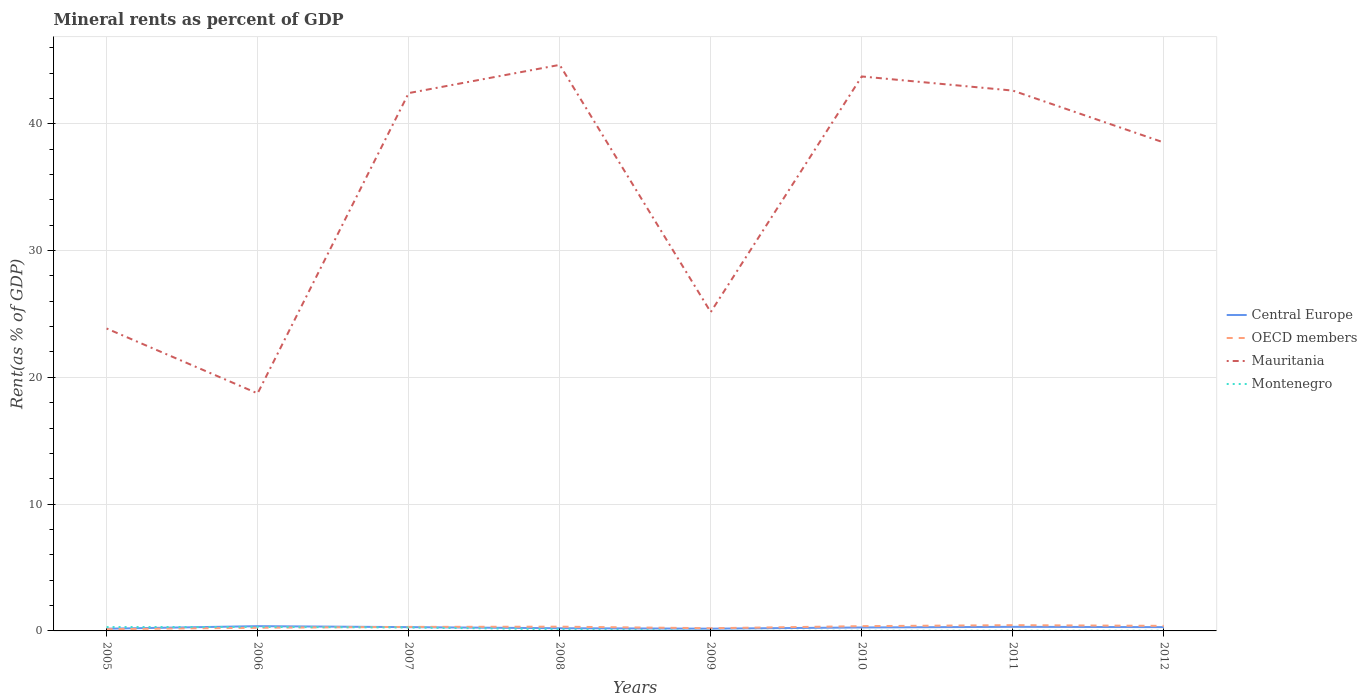How many different coloured lines are there?
Keep it short and to the point. 4. Does the line corresponding to OECD members intersect with the line corresponding to Montenegro?
Provide a succinct answer. Yes. Is the number of lines equal to the number of legend labels?
Keep it short and to the point. Yes. Across all years, what is the maximum mineral rent in Mauritania?
Make the answer very short. 18.73. In which year was the mineral rent in OECD members maximum?
Give a very brief answer. 2005. What is the total mineral rent in OECD members in the graph?
Offer a very short reply. -0.04. What is the difference between the highest and the second highest mineral rent in Montenegro?
Offer a very short reply. 0.3. How many years are there in the graph?
Your answer should be compact. 8. What is the difference between two consecutive major ticks on the Y-axis?
Provide a succinct answer. 10. Are the values on the major ticks of Y-axis written in scientific E-notation?
Make the answer very short. No. Does the graph contain any zero values?
Keep it short and to the point. No. Does the graph contain grids?
Make the answer very short. Yes. Where does the legend appear in the graph?
Ensure brevity in your answer.  Center right. What is the title of the graph?
Your answer should be very brief. Mineral rents as percent of GDP. What is the label or title of the X-axis?
Provide a succinct answer. Years. What is the label or title of the Y-axis?
Offer a very short reply. Rent(as % of GDP). What is the Rent(as % of GDP) in Central Europe in 2005?
Provide a short and direct response. 0.18. What is the Rent(as % of GDP) in OECD members in 2005?
Provide a succinct answer. 0.14. What is the Rent(as % of GDP) of Mauritania in 2005?
Ensure brevity in your answer.  23.85. What is the Rent(as % of GDP) in Montenegro in 2005?
Offer a terse response. 0.3. What is the Rent(as % of GDP) of Central Europe in 2006?
Your response must be concise. 0.38. What is the Rent(as % of GDP) of OECD members in 2006?
Give a very brief answer. 0.25. What is the Rent(as % of GDP) of Mauritania in 2006?
Offer a terse response. 18.73. What is the Rent(as % of GDP) of Montenegro in 2006?
Make the answer very short. 0.31. What is the Rent(as % of GDP) of Central Europe in 2007?
Provide a short and direct response. 0.3. What is the Rent(as % of GDP) of OECD members in 2007?
Your answer should be very brief. 0.32. What is the Rent(as % of GDP) in Mauritania in 2007?
Your answer should be compact. 42.42. What is the Rent(as % of GDP) of Montenegro in 2007?
Give a very brief answer. 0.27. What is the Rent(as % of GDP) of Central Europe in 2008?
Your response must be concise. 0.21. What is the Rent(as % of GDP) of OECD members in 2008?
Ensure brevity in your answer.  0.34. What is the Rent(as % of GDP) in Mauritania in 2008?
Ensure brevity in your answer.  44.64. What is the Rent(as % of GDP) of Montenegro in 2008?
Provide a succinct answer. 0.13. What is the Rent(as % of GDP) of Central Europe in 2009?
Give a very brief answer. 0.18. What is the Rent(as % of GDP) of OECD members in 2009?
Your answer should be compact. 0.21. What is the Rent(as % of GDP) in Mauritania in 2009?
Your response must be concise. 25.14. What is the Rent(as % of GDP) in Montenegro in 2009?
Make the answer very short. 0.01. What is the Rent(as % of GDP) in Central Europe in 2010?
Ensure brevity in your answer.  0.27. What is the Rent(as % of GDP) in OECD members in 2010?
Make the answer very short. 0.38. What is the Rent(as % of GDP) of Mauritania in 2010?
Offer a terse response. 43.73. What is the Rent(as % of GDP) in Montenegro in 2010?
Provide a succinct answer. 0.02. What is the Rent(as % of GDP) of Central Europe in 2011?
Provide a short and direct response. 0.32. What is the Rent(as % of GDP) of OECD members in 2011?
Give a very brief answer. 0.46. What is the Rent(as % of GDP) in Mauritania in 2011?
Make the answer very short. 42.62. What is the Rent(as % of GDP) in Montenegro in 2011?
Make the answer very short. 0.02. What is the Rent(as % of GDP) in Central Europe in 2012?
Your answer should be very brief. 0.3. What is the Rent(as % of GDP) of OECD members in 2012?
Make the answer very short. 0.4. What is the Rent(as % of GDP) in Mauritania in 2012?
Ensure brevity in your answer.  38.52. What is the Rent(as % of GDP) of Montenegro in 2012?
Your answer should be very brief. 0.01. Across all years, what is the maximum Rent(as % of GDP) of Central Europe?
Provide a short and direct response. 0.38. Across all years, what is the maximum Rent(as % of GDP) in OECD members?
Offer a very short reply. 0.46. Across all years, what is the maximum Rent(as % of GDP) of Mauritania?
Provide a short and direct response. 44.64. Across all years, what is the maximum Rent(as % of GDP) in Montenegro?
Your response must be concise. 0.31. Across all years, what is the minimum Rent(as % of GDP) in Central Europe?
Offer a very short reply. 0.18. Across all years, what is the minimum Rent(as % of GDP) in OECD members?
Offer a very short reply. 0.14. Across all years, what is the minimum Rent(as % of GDP) of Mauritania?
Your response must be concise. 18.73. Across all years, what is the minimum Rent(as % of GDP) in Montenegro?
Keep it short and to the point. 0.01. What is the total Rent(as % of GDP) of Central Europe in the graph?
Your response must be concise. 2.14. What is the total Rent(as % of GDP) in OECD members in the graph?
Provide a short and direct response. 2.48. What is the total Rent(as % of GDP) of Mauritania in the graph?
Provide a short and direct response. 279.66. What is the total Rent(as % of GDP) of Montenegro in the graph?
Give a very brief answer. 1.08. What is the difference between the Rent(as % of GDP) in Central Europe in 2005 and that in 2006?
Provide a succinct answer. -0.2. What is the difference between the Rent(as % of GDP) of OECD members in 2005 and that in 2006?
Your answer should be very brief. -0.11. What is the difference between the Rent(as % of GDP) in Mauritania in 2005 and that in 2006?
Offer a terse response. 5.12. What is the difference between the Rent(as % of GDP) of Montenegro in 2005 and that in 2006?
Offer a terse response. -0.01. What is the difference between the Rent(as % of GDP) of Central Europe in 2005 and that in 2007?
Offer a very short reply. -0.12. What is the difference between the Rent(as % of GDP) of OECD members in 2005 and that in 2007?
Provide a short and direct response. -0.18. What is the difference between the Rent(as % of GDP) of Mauritania in 2005 and that in 2007?
Make the answer very short. -18.57. What is the difference between the Rent(as % of GDP) in Montenegro in 2005 and that in 2007?
Offer a terse response. 0.03. What is the difference between the Rent(as % of GDP) in Central Europe in 2005 and that in 2008?
Give a very brief answer. -0.04. What is the difference between the Rent(as % of GDP) of OECD members in 2005 and that in 2008?
Ensure brevity in your answer.  -0.2. What is the difference between the Rent(as % of GDP) of Mauritania in 2005 and that in 2008?
Your answer should be very brief. -20.79. What is the difference between the Rent(as % of GDP) in Montenegro in 2005 and that in 2008?
Your answer should be very brief. 0.18. What is the difference between the Rent(as % of GDP) in Central Europe in 2005 and that in 2009?
Provide a short and direct response. -0. What is the difference between the Rent(as % of GDP) in OECD members in 2005 and that in 2009?
Offer a terse response. -0.08. What is the difference between the Rent(as % of GDP) in Mauritania in 2005 and that in 2009?
Ensure brevity in your answer.  -1.29. What is the difference between the Rent(as % of GDP) of Montenegro in 2005 and that in 2009?
Offer a very short reply. 0.29. What is the difference between the Rent(as % of GDP) of Central Europe in 2005 and that in 2010?
Keep it short and to the point. -0.1. What is the difference between the Rent(as % of GDP) of OECD members in 2005 and that in 2010?
Your answer should be compact. -0.24. What is the difference between the Rent(as % of GDP) in Mauritania in 2005 and that in 2010?
Give a very brief answer. -19.88. What is the difference between the Rent(as % of GDP) in Montenegro in 2005 and that in 2010?
Your answer should be very brief. 0.29. What is the difference between the Rent(as % of GDP) in Central Europe in 2005 and that in 2011?
Give a very brief answer. -0.15. What is the difference between the Rent(as % of GDP) in OECD members in 2005 and that in 2011?
Keep it short and to the point. -0.32. What is the difference between the Rent(as % of GDP) in Mauritania in 2005 and that in 2011?
Provide a succinct answer. -18.76. What is the difference between the Rent(as % of GDP) in Montenegro in 2005 and that in 2011?
Make the answer very short. 0.29. What is the difference between the Rent(as % of GDP) in Central Europe in 2005 and that in 2012?
Offer a very short reply. -0.12. What is the difference between the Rent(as % of GDP) in OECD members in 2005 and that in 2012?
Give a very brief answer. -0.26. What is the difference between the Rent(as % of GDP) in Mauritania in 2005 and that in 2012?
Your answer should be compact. -14.67. What is the difference between the Rent(as % of GDP) in Montenegro in 2005 and that in 2012?
Offer a very short reply. 0.29. What is the difference between the Rent(as % of GDP) of Central Europe in 2006 and that in 2007?
Your answer should be very brief. 0.08. What is the difference between the Rent(as % of GDP) of OECD members in 2006 and that in 2007?
Provide a short and direct response. -0.07. What is the difference between the Rent(as % of GDP) in Mauritania in 2006 and that in 2007?
Offer a very short reply. -23.69. What is the difference between the Rent(as % of GDP) in Montenegro in 2006 and that in 2007?
Your answer should be very brief. 0.04. What is the difference between the Rent(as % of GDP) of Central Europe in 2006 and that in 2008?
Your answer should be compact. 0.16. What is the difference between the Rent(as % of GDP) in OECD members in 2006 and that in 2008?
Provide a succinct answer. -0.09. What is the difference between the Rent(as % of GDP) in Mauritania in 2006 and that in 2008?
Offer a terse response. -25.91. What is the difference between the Rent(as % of GDP) in Montenegro in 2006 and that in 2008?
Make the answer very short. 0.19. What is the difference between the Rent(as % of GDP) of Central Europe in 2006 and that in 2009?
Provide a succinct answer. 0.2. What is the difference between the Rent(as % of GDP) of OECD members in 2006 and that in 2009?
Provide a short and direct response. 0.03. What is the difference between the Rent(as % of GDP) in Mauritania in 2006 and that in 2009?
Provide a short and direct response. -6.41. What is the difference between the Rent(as % of GDP) of Montenegro in 2006 and that in 2009?
Offer a terse response. 0.3. What is the difference between the Rent(as % of GDP) in Central Europe in 2006 and that in 2010?
Offer a terse response. 0.1. What is the difference between the Rent(as % of GDP) in OECD members in 2006 and that in 2010?
Your answer should be very brief. -0.13. What is the difference between the Rent(as % of GDP) in Mauritania in 2006 and that in 2010?
Ensure brevity in your answer.  -25. What is the difference between the Rent(as % of GDP) of Montenegro in 2006 and that in 2010?
Keep it short and to the point. 0.3. What is the difference between the Rent(as % of GDP) of Central Europe in 2006 and that in 2011?
Offer a very short reply. 0.05. What is the difference between the Rent(as % of GDP) of OECD members in 2006 and that in 2011?
Provide a short and direct response. -0.21. What is the difference between the Rent(as % of GDP) in Mauritania in 2006 and that in 2011?
Provide a short and direct response. -23.88. What is the difference between the Rent(as % of GDP) in Montenegro in 2006 and that in 2011?
Keep it short and to the point. 0.3. What is the difference between the Rent(as % of GDP) of Central Europe in 2006 and that in 2012?
Your answer should be compact. 0.08. What is the difference between the Rent(as % of GDP) of OECD members in 2006 and that in 2012?
Your response must be concise. -0.15. What is the difference between the Rent(as % of GDP) of Mauritania in 2006 and that in 2012?
Ensure brevity in your answer.  -19.79. What is the difference between the Rent(as % of GDP) in Montenegro in 2006 and that in 2012?
Offer a very short reply. 0.3. What is the difference between the Rent(as % of GDP) in Central Europe in 2007 and that in 2008?
Make the answer very short. 0.09. What is the difference between the Rent(as % of GDP) of OECD members in 2007 and that in 2008?
Keep it short and to the point. -0.02. What is the difference between the Rent(as % of GDP) in Mauritania in 2007 and that in 2008?
Your answer should be compact. -2.23. What is the difference between the Rent(as % of GDP) in Montenegro in 2007 and that in 2008?
Make the answer very short. 0.14. What is the difference between the Rent(as % of GDP) in Central Europe in 2007 and that in 2009?
Give a very brief answer. 0.12. What is the difference between the Rent(as % of GDP) of OECD members in 2007 and that in 2009?
Ensure brevity in your answer.  0.1. What is the difference between the Rent(as % of GDP) of Mauritania in 2007 and that in 2009?
Make the answer very short. 17.27. What is the difference between the Rent(as % of GDP) of Montenegro in 2007 and that in 2009?
Provide a short and direct response. 0.26. What is the difference between the Rent(as % of GDP) in Central Europe in 2007 and that in 2010?
Your response must be concise. 0.03. What is the difference between the Rent(as % of GDP) in OECD members in 2007 and that in 2010?
Provide a succinct answer. -0.06. What is the difference between the Rent(as % of GDP) of Mauritania in 2007 and that in 2010?
Provide a short and direct response. -1.31. What is the difference between the Rent(as % of GDP) of Montenegro in 2007 and that in 2010?
Your answer should be very brief. 0.26. What is the difference between the Rent(as % of GDP) of Central Europe in 2007 and that in 2011?
Your response must be concise. -0.02. What is the difference between the Rent(as % of GDP) in OECD members in 2007 and that in 2011?
Keep it short and to the point. -0.14. What is the difference between the Rent(as % of GDP) of Mauritania in 2007 and that in 2011?
Provide a succinct answer. -0.2. What is the difference between the Rent(as % of GDP) of Montenegro in 2007 and that in 2011?
Provide a succinct answer. 0.26. What is the difference between the Rent(as % of GDP) in OECD members in 2007 and that in 2012?
Keep it short and to the point. -0.08. What is the difference between the Rent(as % of GDP) in Mauritania in 2007 and that in 2012?
Your response must be concise. 3.9. What is the difference between the Rent(as % of GDP) of Montenegro in 2007 and that in 2012?
Offer a terse response. 0.26. What is the difference between the Rent(as % of GDP) in Central Europe in 2008 and that in 2009?
Ensure brevity in your answer.  0.03. What is the difference between the Rent(as % of GDP) in OECD members in 2008 and that in 2009?
Your answer should be very brief. 0.12. What is the difference between the Rent(as % of GDP) of Mauritania in 2008 and that in 2009?
Give a very brief answer. 19.5. What is the difference between the Rent(as % of GDP) of Montenegro in 2008 and that in 2009?
Keep it short and to the point. 0.12. What is the difference between the Rent(as % of GDP) in Central Europe in 2008 and that in 2010?
Keep it short and to the point. -0.06. What is the difference between the Rent(as % of GDP) of OECD members in 2008 and that in 2010?
Provide a succinct answer. -0.04. What is the difference between the Rent(as % of GDP) of Mauritania in 2008 and that in 2010?
Your answer should be very brief. 0.91. What is the difference between the Rent(as % of GDP) of Montenegro in 2008 and that in 2010?
Keep it short and to the point. 0.11. What is the difference between the Rent(as % of GDP) of Central Europe in 2008 and that in 2011?
Keep it short and to the point. -0.11. What is the difference between the Rent(as % of GDP) in OECD members in 2008 and that in 2011?
Offer a terse response. -0.12. What is the difference between the Rent(as % of GDP) of Mauritania in 2008 and that in 2011?
Offer a very short reply. 2.03. What is the difference between the Rent(as % of GDP) of Montenegro in 2008 and that in 2011?
Your response must be concise. 0.11. What is the difference between the Rent(as % of GDP) of Central Europe in 2008 and that in 2012?
Make the answer very short. -0.09. What is the difference between the Rent(as % of GDP) in OECD members in 2008 and that in 2012?
Your response must be concise. -0.06. What is the difference between the Rent(as % of GDP) of Mauritania in 2008 and that in 2012?
Make the answer very short. 6.12. What is the difference between the Rent(as % of GDP) of Montenegro in 2008 and that in 2012?
Your answer should be very brief. 0.11. What is the difference between the Rent(as % of GDP) of Central Europe in 2009 and that in 2010?
Your answer should be compact. -0.09. What is the difference between the Rent(as % of GDP) of OECD members in 2009 and that in 2010?
Your answer should be compact. -0.16. What is the difference between the Rent(as % of GDP) in Mauritania in 2009 and that in 2010?
Ensure brevity in your answer.  -18.59. What is the difference between the Rent(as % of GDP) of Montenegro in 2009 and that in 2010?
Provide a short and direct response. -0. What is the difference between the Rent(as % of GDP) of Central Europe in 2009 and that in 2011?
Offer a very short reply. -0.15. What is the difference between the Rent(as % of GDP) in OECD members in 2009 and that in 2011?
Make the answer very short. -0.24. What is the difference between the Rent(as % of GDP) in Mauritania in 2009 and that in 2011?
Keep it short and to the point. -17.47. What is the difference between the Rent(as % of GDP) of Montenegro in 2009 and that in 2011?
Offer a very short reply. -0. What is the difference between the Rent(as % of GDP) of Central Europe in 2009 and that in 2012?
Your response must be concise. -0.12. What is the difference between the Rent(as % of GDP) in OECD members in 2009 and that in 2012?
Provide a short and direct response. -0.19. What is the difference between the Rent(as % of GDP) in Mauritania in 2009 and that in 2012?
Your response must be concise. -13.38. What is the difference between the Rent(as % of GDP) of Montenegro in 2009 and that in 2012?
Provide a short and direct response. -0. What is the difference between the Rent(as % of GDP) of Central Europe in 2010 and that in 2011?
Keep it short and to the point. -0.05. What is the difference between the Rent(as % of GDP) of OECD members in 2010 and that in 2011?
Ensure brevity in your answer.  -0.08. What is the difference between the Rent(as % of GDP) in Mauritania in 2010 and that in 2011?
Offer a terse response. 1.11. What is the difference between the Rent(as % of GDP) in Montenegro in 2010 and that in 2011?
Offer a very short reply. -0. What is the difference between the Rent(as % of GDP) of Central Europe in 2010 and that in 2012?
Offer a terse response. -0.03. What is the difference between the Rent(as % of GDP) of OECD members in 2010 and that in 2012?
Your response must be concise. -0.02. What is the difference between the Rent(as % of GDP) in Mauritania in 2010 and that in 2012?
Offer a terse response. 5.21. What is the difference between the Rent(as % of GDP) in Central Europe in 2011 and that in 2012?
Offer a very short reply. 0.02. What is the difference between the Rent(as % of GDP) in OECD members in 2011 and that in 2012?
Make the answer very short. 0.06. What is the difference between the Rent(as % of GDP) in Mauritania in 2011 and that in 2012?
Provide a succinct answer. 4.1. What is the difference between the Rent(as % of GDP) of Montenegro in 2011 and that in 2012?
Offer a terse response. 0. What is the difference between the Rent(as % of GDP) of Central Europe in 2005 and the Rent(as % of GDP) of OECD members in 2006?
Provide a short and direct response. -0.07. What is the difference between the Rent(as % of GDP) in Central Europe in 2005 and the Rent(as % of GDP) in Mauritania in 2006?
Ensure brevity in your answer.  -18.56. What is the difference between the Rent(as % of GDP) in Central Europe in 2005 and the Rent(as % of GDP) in Montenegro in 2006?
Your answer should be very brief. -0.14. What is the difference between the Rent(as % of GDP) in OECD members in 2005 and the Rent(as % of GDP) in Mauritania in 2006?
Provide a short and direct response. -18.6. What is the difference between the Rent(as % of GDP) in OECD members in 2005 and the Rent(as % of GDP) in Montenegro in 2006?
Offer a terse response. -0.18. What is the difference between the Rent(as % of GDP) in Mauritania in 2005 and the Rent(as % of GDP) in Montenegro in 2006?
Keep it short and to the point. 23.54. What is the difference between the Rent(as % of GDP) of Central Europe in 2005 and the Rent(as % of GDP) of OECD members in 2007?
Offer a terse response. -0.14. What is the difference between the Rent(as % of GDP) of Central Europe in 2005 and the Rent(as % of GDP) of Mauritania in 2007?
Make the answer very short. -42.24. What is the difference between the Rent(as % of GDP) in Central Europe in 2005 and the Rent(as % of GDP) in Montenegro in 2007?
Your answer should be very brief. -0.1. What is the difference between the Rent(as % of GDP) in OECD members in 2005 and the Rent(as % of GDP) in Mauritania in 2007?
Offer a terse response. -42.28. What is the difference between the Rent(as % of GDP) of OECD members in 2005 and the Rent(as % of GDP) of Montenegro in 2007?
Your answer should be very brief. -0.14. What is the difference between the Rent(as % of GDP) of Mauritania in 2005 and the Rent(as % of GDP) of Montenegro in 2007?
Give a very brief answer. 23.58. What is the difference between the Rent(as % of GDP) of Central Europe in 2005 and the Rent(as % of GDP) of OECD members in 2008?
Ensure brevity in your answer.  -0.16. What is the difference between the Rent(as % of GDP) of Central Europe in 2005 and the Rent(as % of GDP) of Mauritania in 2008?
Keep it short and to the point. -44.47. What is the difference between the Rent(as % of GDP) of Central Europe in 2005 and the Rent(as % of GDP) of Montenegro in 2008?
Offer a very short reply. 0.05. What is the difference between the Rent(as % of GDP) in OECD members in 2005 and the Rent(as % of GDP) in Mauritania in 2008?
Ensure brevity in your answer.  -44.51. What is the difference between the Rent(as % of GDP) in OECD members in 2005 and the Rent(as % of GDP) in Montenegro in 2008?
Your response must be concise. 0.01. What is the difference between the Rent(as % of GDP) of Mauritania in 2005 and the Rent(as % of GDP) of Montenegro in 2008?
Keep it short and to the point. 23.72. What is the difference between the Rent(as % of GDP) of Central Europe in 2005 and the Rent(as % of GDP) of OECD members in 2009?
Offer a terse response. -0.04. What is the difference between the Rent(as % of GDP) in Central Europe in 2005 and the Rent(as % of GDP) in Mauritania in 2009?
Ensure brevity in your answer.  -24.97. What is the difference between the Rent(as % of GDP) of Central Europe in 2005 and the Rent(as % of GDP) of Montenegro in 2009?
Offer a very short reply. 0.16. What is the difference between the Rent(as % of GDP) of OECD members in 2005 and the Rent(as % of GDP) of Mauritania in 2009?
Offer a terse response. -25.01. What is the difference between the Rent(as % of GDP) in OECD members in 2005 and the Rent(as % of GDP) in Montenegro in 2009?
Provide a short and direct response. 0.12. What is the difference between the Rent(as % of GDP) of Mauritania in 2005 and the Rent(as % of GDP) of Montenegro in 2009?
Offer a terse response. 23.84. What is the difference between the Rent(as % of GDP) in Central Europe in 2005 and the Rent(as % of GDP) in OECD members in 2010?
Offer a terse response. -0.2. What is the difference between the Rent(as % of GDP) of Central Europe in 2005 and the Rent(as % of GDP) of Mauritania in 2010?
Give a very brief answer. -43.55. What is the difference between the Rent(as % of GDP) in Central Europe in 2005 and the Rent(as % of GDP) in Montenegro in 2010?
Your answer should be compact. 0.16. What is the difference between the Rent(as % of GDP) of OECD members in 2005 and the Rent(as % of GDP) of Mauritania in 2010?
Make the answer very short. -43.59. What is the difference between the Rent(as % of GDP) of OECD members in 2005 and the Rent(as % of GDP) of Montenegro in 2010?
Ensure brevity in your answer.  0.12. What is the difference between the Rent(as % of GDP) of Mauritania in 2005 and the Rent(as % of GDP) of Montenegro in 2010?
Your answer should be very brief. 23.84. What is the difference between the Rent(as % of GDP) in Central Europe in 2005 and the Rent(as % of GDP) in OECD members in 2011?
Your answer should be very brief. -0.28. What is the difference between the Rent(as % of GDP) of Central Europe in 2005 and the Rent(as % of GDP) of Mauritania in 2011?
Provide a short and direct response. -42.44. What is the difference between the Rent(as % of GDP) of Central Europe in 2005 and the Rent(as % of GDP) of Montenegro in 2011?
Your response must be concise. 0.16. What is the difference between the Rent(as % of GDP) of OECD members in 2005 and the Rent(as % of GDP) of Mauritania in 2011?
Provide a short and direct response. -42.48. What is the difference between the Rent(as % of GDP) in OECD members in 2005 and the Rent(as % of GDP) in Montenegro in 2011?
Offer a terse response. 0.12. What is the difference between the Rent(as % of GDP) in Mauritania in 2005 and the Rent(as % of GDP) in Montenegro in 2011?
Provide a short and direct response. 23.84. What is the difference between the Rent(as % of GDP) of Central Europe in 2005 and the Rent(as % of GDP) of OECD members in 2012?
Provide a succinct answer. -0.22. What is the difference between the Rent(as % of GDP) in Central Europe in 2005 and the Rent(as % of GDP) in Mauritania in 2012?
Make the answer very short. -38.34. What is the difference between the Rent(as % of GDP) of Central Europe in 2005 and the Rent(as % of GDP) of Montenegro in 2012?
Provide a succinct answer. 0.16. What is the difference between the Rent(as % of GDP) in OECD members in 2005 and the Rent(as % of GDP) in Mauritania in 2012?
Ensure brevity in your answer.  -38.38. What is the difference between the Rent(as % of GDP) of OECD members in 2005 and the Rent(as % of GDP) of Montenegro in 2012?
Keep it short and to the point. 0.12. What is the difference between the Rent(as % of GDP) in Mauritania in 2005 and the Rent(as % of GDP) in Montenegro in 2012?
Keep it short and to the point. 23.84. What is the difference between the Rent(as % of GDP) in Central Europe in 2006 and the Rent(as % of GDP) in OECD members in 2007?
Provide a short and direct response. 0.06. What is the difference between the Rent(as % of GDP) of Central Europe in 2006 and the Rent(as % of GDP) of Mauritania in 2007?
Offer a terse response. -42.04. What is the difference between the Rent(as % of GDP) of Central Europe in 2006 and the Rent(as % of GDP) of Montenegro in 2007?
Offer a terse response. 0.1. What is the difference between the Rent(as % of GDP) of OECD members in 2006 and the Rent(as % of GDP) of Mauritania in 2007?
Keep it short and to the point. -42.17. What is the difference between the Rent(as % of GDP) of OECD members in 2006 and the Rent(as % of GDP) of Montenegro in 2007?
Ensure brevity in your answer.  -0.02. What is the difference between the Rent(as % of GDP) in Mauritania in 2006 and the Rent(as % of GDP) in Montenegro in 2007?
Your response must be concise. 18.46. What is the difference between the Rent(as % of GDP) in Central Europe in 2006 and the Rent(as % of GDP) in OECD members in 2008?
Give a very brief answer. 0.04. What is the difference between the Rent(as % of GDP) in Central Europe in 2006 and the Rent(as % of GDP) in Mauritania in 2008?
Keep it short and to the point. -44.27. What is the difference between the Rent(as % of GDP) in Central Europe in 2006 and the Rent(as % of GDP) in Montenegro in 2008?
Your answer should be very brief. 0.25. What is the difference between the Rent(as % of GDP) in OECD members in 2006 and the Rent(as % of GDP) in Mauritania in 2008?
Offer a terse response. -44.4. What is the difference between the Rent(as % of GDP) in OECD members in 2006 and the Rent(as % of GDP) in Montenegro in 2008?
Ensure brevity in your answer.  0.12. What is the difference between the Rent(as % of GDP) of Mauritania in 2006 and the Rent(as % of GDP) of Montenegro in 2008?
Give a very brief answer. 18.6. What is the difference between the Rent(as % of GDP) of Central Europe in 2006 and the Rent(as % of GDP) of OECD members in 2009?
Your answer should be compact. 0.16. What is the difference between the Rent(as % of GDP) in Central Europe in 2006 and the Rent(as % of GDP) in Mauritania in 2009?
Provide a short and direct response. -24.77. What is the difference between the Rent(as % of GDP) of Central Europe in 2006 and the Rent(as % of GDP) of Montenegro in 2009?
Give a very brief answer. 0.36. What is the difference between the Rent(as % of GDP) in OECD members in 2006 and the Rent(as % of GDP) in Mauritania in 2009?
Your answer should be compact. -24.9. What is the difference between the Rent(as % of GDP) of OECD members in 2006 and the Rent(as % of GDP) of Montenegro in 2009?
Offer a terse response. 0.23. What is the difference between the Rent(as % of GDP) of Mauritania in 2006 and the Rent(as % of GDP) of Montenegro in 2009?
Offer a terse response. 18.72. What is the difference between the Rent(as % of GDP) of Central Europe in 2006 and the Rent(as % of GDP) of OECD members in 2010?
Make the answer very short. -0. What is the difference between the Rent(as % of GDP) of Central Europe in 2006 and the Rent(as % of GDP) of Mauritania in 2010?
Your answer should be very brief. -43.35. What is the difference between the Rent(as % of GDP) of Central Europe in 2006 and the Rent(as % of GDP) of Montenegro in 2010?
Offer a terse response. 0.36. What is the difference between the Rent(as % of GDP) in OECD members in 2006 and the Rent(as % of GDP) in Mauritania in 2010?
Your answer should be very brief. -43.48. What is the difference between the Rent(as % of GDP) in OECD members in 2006 and the Rent(as % of GDP) in Montenegro in 2010?
Your answer should be very brief. 0.23. What is the difference between the Rent(as % of GDP) of Mauritania in 2006 and the Rent(as % of GDP) of Montenegro in 2010?
Provide a succinct answer. 18.72. What is the difference between the Rent(as % of GDP) of Central Europe in 2006 and the Rent(as % of GDP) of OECD members in 2011?
Make the answer very short. -0.08. What is the difference between the Rent(as % of GDP) of Central Europe in 2006 and the Rent(as % of GDP) of Mauritania in 2011?
Your answer should be very brief. -42.24. What is the difference between the Rent(as % of GDP) in Central Europe in 2006 and the Rent(as % of GDP) in Montenegro in 2011?
Ensure brevity in your answer.  0.36. What is the difference between the Rent(as % of GDP) of OECD members in 2006 and the Rent(as % of GDP) of Mauritania in 2011?
Ensure brevity in your answer.  -42.37. What is the difference between the Rent(as % of GDP) of OECD members in 2006 and the Rent(as % of GDP) of Montenegro in 2011?
Keep it short and to the point. 0.23. What is the difference between the Rent(as % of GDP) in Mauritania in 2006 and the Rent(as % of GDP) in Montenegro in 2011?
Your answer should be very brief. 18.72. What is the difference between the Rent(as % of GDP) of Central Europe in 2006 and the Rent(as % of GDP) of OECD members in 2012?
Keep it short and to the point. -0.02. What is the difference between the Rent(as % of GDP) in Central Europe in 2006 and the Rent(as % of GDP) in Mauritania in 2012?
Keep it short and to the point. -38.14. What is the difference between the Rent(as % of GDP) of Central Europe in 2006 and the Rent(as % of GDP) of Montenegro in 2012?
Offer a terse response. 0.36. What is the difference between the Rent(as % of GDP) in OECD members in 2006 and the Rent(as % of GDP) in Mauritania in 2012?
Your answer should be compact. -38.27. What is the difference between the Rent(as % of GDP) in OECD members in 2006 and the Rent(as % of GDP) in Montenegro in 2012?
Your response must be concise. 0.23. What is the difference between the Rent(as % of GDP) of Mauritania in 2006 and the Rent(as % of GDP) of Montenegro in 2012?
Offer a very short reply. 18.72. What is the difference between the Rent(as % of GDP) of Central Europe in 2007 and the Rent(as % of GDP) of OECD members in 2008?
Provide a short and direct response. -0.04. What is the difference between the Rent(as % of GDP) in Central Europe in 2007 and the Rent(as % of GDP) in Mauritania in 2008?
Your answer should be compact. -44.34. What is the difference between the Rent(as % of GDP) of Central Europe in 2007 and the Rent(as % of GDP) of Montenegro in 2008?
Offer a very short reply. 0.17. What is the difference between the Rent(as % of GDP) of OECD members in 2007 and the Rent(as % of GDP) of Mauritania in 2008?
Keep it short and to the point. -44.33. What is the difference between the Rent(as % of GDP) in OECD members in 2007 and the Rent(as % of GDP) in Montenegro in 2008?
Keep it short and to the point. 0.19. What is the difference between the Rent(as % of GDP) in Mauritania in 2007 and the Rent(as % of GDP) in Montenegro in 2008?
Keep it short and to the point. 42.29. What is the difference between the Rent(as % of GDP) of Central Europe in 2007 and the Rent(as % of GDP) of OECD members in 2009?
Give a very brief answer. 0.09. What is the difference between the Rent(as % of GDP) of Central Europe in 2007 and the Rent(as % of GDP) of Mauritania in 2009?
Offer a very short reply. -24.85. What is the difference between the Rent(as % of GDP) of Central Europe in 2007 and the Rent(as % of GDP) of Montenegro in 2009?
Make the answer very short. 0.29. What is the difference between the Rent(as % of GDP) of OECD members in 2007 and the Rent(as % of GDP) of Mauritania in 2009?
Give a very brief answer. -24.83. What is the difference between the Rent(as % of GDP) in OECD members in 2007 and the Rent(as % of GDP) in Montenegro in 2009?
Keep it short and to the point. 0.3. What is the difference between the Rent(as % of GDP) in Mauritania in 2007 and the Rent(as % of GDP) in Montenegro in 2009?
Provide a short and direct response. 42.41. What is the difference between the Rent(as % of GDP) in Central Europe in 2007 and the Rent(as % of GDP) in OECD members in 2010?
Provide a succinct answer. -0.08. What is the difference between the Rent(as % of GDP) in Central Europe in 2007 and the Rent(as % of GDP) in Mauritania in 2010?
Provide a short and direct response. -43.43. What is the difference between the Rent(as % of GDP) in Central Europe in 2007 and the Rent(as % of GDP) in Montenegro in 2010?
Make the answer very short. 0.28. What is the difference between the Rent(as % of GDP) in OECD members in 2007 and the Rent(as % of GDP) in Mauritania in 2010?
Offer a terse response. -43.41. What is the difference between the Rent(as % of GDP) of OECD members in 2007 and the Rent(as % of GDP) of Montenegro in 2010?
Ensure brevity in your answer.  0.3. What is the difference between the Rent(as % of GDP) of Mauritania in 2007 and the Rent(as % of GDP) of Montenegro in 2010?
Your answer should be compact. 42.4. What is the difference between the Rent(as % of GDP) of Central Europe in 2007 and the Rent(as % of GDP) of OECD members in 2011?
Ensure brevity in your answer.  -0.16. What is the difference between the Rent(as % of GDP) of Central Europe in 2007 and the Rent(as % of GDP) of Mauritania in 2011?
Ensure brevity in your answer.  -42.32. What is the difference between the Rent(as % of GDP) in Central Europe in 2007 and the Rent(as % of GDP) in Montenegro in 2011?
Make the answer very short. 0.28. What is the difference between the Rent(as % of GDP) in OECD members in 2007 and the Rent(as % of GDP) in Mauritania in 2011?
Offer a very short reply. -42.3. What is the difference between the Rent(as % of GDP) in OECD members in 2007 and the Rent(as % of GDP) in Montenegro in 2011?
Your answer should be very brief. 0.3. What is the difference between the Rent(as % of GDP) in Mauritania in 2007 and the Rent(as % of GDP) in Montenegro in 2011?
Offer a very short reply. 42.4. What is the difference between the Rent(as % of GDP) of Central Europe in 2007 and the Rent(as % of GDP) of OECD members in 2012?
Provide a succinct answer. -0.1. What is the difference between the Rent(as % of GDP) of Central Europe in 2007 and the Rent(as % of GDP) of Mauritania in 2012?
Your answer should be compact. -38.22. What is the difference between the Rent(as % of GDP) of Central Europe in 2007 and the Rent(as % of GDP) of Montenegro in 2012?
Give a very brief answer. 0.28. What is the difference between the Rent(as % of GDP) in OECD members in 2007 and the Rent(as % of GDP) in Mauritania in 2012?
Ensure brevity in your answer.  -38.2. What is the difference between the Rent(as % of GDP) in OECD members in 2007 and the Rent(as % of GDP) in Montenegro in 2012?
Your answer should be very brief. 0.3. What is the difference between the Rent(as % of GDP) in Mauritania in 2007 and the Rent(as % of GDP) in Montenegro in 2012?
Provide a succinct answer. 42.4. What is the difference between the Rent(as % of GDP) of Central Europe in 2008 and the Rent(as % of GDP) of OECD members in 2009?
Offer a terse response. -0. What is the difference between the Rent(as % of GDP) in Central Europe in 2008 and the Rent(as % of GDP) in Mauritania in 2009?
Ensure brevity in your answer.  -24.93. What is the difference between the Rent(as % of GDP) of Central Europe in 2008 and the Rent(as % of GDP) of Montenegro in 2009?
Your response must be concise. 0.2. What is the difference between the Rent(as % of GDP) in OECD members in 2008 and the Rent(as % of GDP) in Mauritania in 2009?
Offer a very short reply. -24.81. What is the difference between the Rent(as % of GDP) in OECD members in 2008 and the Rent(as % of GDP) in Montenegro in 2009?
Your response must be concise. 0.32. What is the difference between the Rent(as % of GDP) of Mauritania in 2008 and the Rent(as % of GDP) of Montenegro in 2009?
Provide a short and direct response. 44.63. What is the difference between the Rent(as % of GDP) of Central Europe in 2008 and the Rent(as % of GDP) of OECD members in 2010?
Your answer should be very brief. -0.16. What is the difference between the Rent(as % of GDP) of Central Europe in 2008 and the Rent(as % of GDP) of Mauritania in 2010?
Offer a terse response. -43.52. What is the difference between the Rent(as % of GDP) in Central Europe in 2008 and the Rent(as % of GDP) in Montenegro in 2010?
Your answer should be very brief. 0.2. What is the difference between the Rent(as % of GDP) in OECD members in 2008 and the Rent(as % of GDP) in Mauritania in 2010?
Ensure brevity in your answer.  -43.39. What is the difference between the Rent(as % of GDP) of OECD members in 2008 and the Rent(as % of GDP) of Montenegro in 2010?
Offer a terse response. 0.32. What is the difference between the Rent(as % of GDP) in Mauritania in 2008 and the Rent(as % of GDP) in Montenegro in 2010?
Keep it short and to the point. 44.63. What is the difference between the Rent(as % of GDP) in Central Europe in 2008 and the Rent(as % of GDP) in OECD members in 2011?
Provide a succinct answer. -0.24. What is the difference between the Rent(as % of GDP) in Central Europe in 2008 and the Rent(as % of GDP) in Mauritania in 2011?
Provide a short and direct response. -42.4. What is the difference between the Rent(as % of GDP) of Central Europe in 2008 and the Rent(as % of GDP) of Montenegro in 2011?
Make the answer very short. 0.2. What is the difference between the Rent(as % of GDP) in OECD members in 2008 and the Rent(as % of GDP) in Mauritania in 2011?
Give a very brief answer. -42.28. What is the difference between the Rent(as % of GDP) of OECD members in 2008 and the Rent(as % of GDP) of Montenegro in 2011?
Your answer should be compact. 0.32. What is the difference between the Rent(as % of GDP) of Mauritania in 2008 and the Rent(as % of GDP) of Montenegro in 2011?
Your answer should be compact. 44.63. What is the difference between the Rent(as % of GDP) of Central Europe in 2008 and the Rent(as % of GDP) of OECD members in 2012?
Your response must be concise. -0.19. What is the difference between the Rent(as % of GDP) in Central Europe in 2008 and the Rent(as % of GDP) in Mauritania in 2012?
Your answer should be compact. -38.31. What is the difference between the Rent(as % of GDP) in Central Europe in 2008 and the Rent(as % of GDP) in Montenegro in 2012?
Provide a succinct answer. 0.2. What is the difference between the Rent(as % of GDP) of OECD members in 2008 and the Rent(as % of GDP) of Mauritania in 2012?
Your response must be concise. -38.18. What is the difference between the Rent(as % of GDP) in OECD members in 2008 and the Rent(as % of GDP) in Montenegro in 2012?
Your response must be concise. 0.32. What is the difference between the Rent(as % of GDP) of Mauritania in 2008 and the Rent(as % of GDP) of Montenegro in 2012?
Your response must be concise. 44.63. What is the difference between the Rent(as % of GDP) in Central Europe in 2009 and the Rent(as % of GDP) in OECD members in 2010?
Keep it short and to the point. -0.2. What is the difference between the Rent(as % of GDP) in Central Europe in 2009 and the Rent(as % of GDP) in Mauritania in 2010?
Your answer should be very brief. -43.55. What is the difference between the Rent(as % of GDP) of Central Europe in 2009 and the Rent(as % of GDP) of Montenegro in 2010?
Provide a succinct answer. 0.16. What is the difference between the Rent(as % of GDP) of OECD members in 2009 and the Rent(as % of GDP) of Mauritania in 2010?
Your answer should be compact. -43.52. What is the difference between the Rent(as % of GDP) in OECD members in 2009 and the Rent(as % of GDP) in Montenegro in 2010?
Ensure brevity in your answer.  0.2. What is the difference between the Rent(as % of GDP) of Mauritania in 2009 and the Rent(as % of GDP) of Montenegro in 2010?
Provide a short and direct response. 25.13. What is the difference between the Rent(as % of GDP) in Central Europe in 2009 and the Rent(as % of GDP) in OECD members in 2011?
Your response must be concise. -0.28. What is the difference between the Rent(as % of GDP) in Central Europe in 2009 and the Rent(as % of GDP) in Mauritania in 2011?
Keep it short and to the point. -42.44. What is the difference between the Rent(as % of GDP) of Central Europe in 2009 and the Rent(as % of GDP) of Montenegro in 2011?
Provide a short and direct response. 0.16. What is the difference between the Rent(as % of GDP) in OECD members in 2009 and the Rent(as % of GDP) in Mauritania in 2011?
Your response must be concise. -42.4. What is the difference between the Rent(as % of GDP) in OECD members in 2009 and the Rent(as % of GDP) in Montenegro in 2011?
Your answer should be compact. 0.2. What is the difference between the Rent(as % of GDP) of Mauritania in 2009 and the Rent(as % of GDP) of Montenegro in 2011?
Make the answer very short. 25.13. What is the difference between the Rent(as % of GDP) in Central Europe in 2009 and the Rent(as % of GDP) in OECD members in 2012?
Provide a short and direct response. -0.22. What is the difference between the Rent(as % of GDP) in Central Europe in 2009 and the Rent(as % of GDP) in Mauritania in 2012?
Give a very brief answer. -38.34. What is the difference between the Rent(as % of GDP) of Central Europe in 2009 and the Rent(as % of GDP) of Montenegro in 2012?
Your answer should be very brief. 0.16. What is the difference between the Rent(as % of GDP) in OECD members in 2009 and the Rent(as % of GDP) in Mauritania in 2012?
Provide a short and direct response. -38.31. What is the difference between the Rent(as % of GDP) of OECD members in 2009 and the Rent(as % of GDP) of Montenegro in 2012?
Provide a succinct answer. 0.2. What is the difference between the Rent(as % of GDP) of Mauritania in 2009 and the Rent(as % of GDP) of Montenegro in 2012?
Provide a succinct answer. 25.13. What is the difference between the Rent(as % of GDP) in Central Europe in 2010 and the Rent(as % of GDP) in OECD members in 2011?
Your answer should be compact. -0.18. What is the difference between the Rent(as % of GDP) of Central Europe in 2010 and the Rent(as % of GDP) of Mauritania in 2011?
Give a very brief answer. -42.34. What is the difference between the Rent(as % of GDP) in Central Europe in 2010 and the Rent(as % of GDP) in Montenegro in 2011?
Your response must be concise. 0.26. What is the difference between the Rent(as % of GDP) in OECD members in 2010 and the Rent(as % of GDP) in Mauritania in 2011?
Your answer should be compact. -42.24. What is the difference between the Rent(as % of GDP) in OECD members in 2010 and the Rent(as % of GDP) in Montenegro in 2011?
Give a very brief answer. 0.36. What is the difference between the Rent(as % of GDP) in Mauritania in 2010 and the Rent(as % of GDP) in Montenegro in 2011?
Make the answer very short. 43.71. What is the difference between the Rent(as % of GDP) of Central Europe in 2010 and the Rent(as % of GDP) of OECD members in 2012?
Offer a very short reply. -0.13. What is the difference between the Rent(as % of GDP) of Central Europe in 2010 and the Rent(as % of GDP) of Mauritania in 2012?
Provide a succinct answer. -38.25. What is the difference between the Rent(as % of GDP) of Central Europe in 2010 and the Rent(as % of GDP) of Montenegro in 2012?
Offer a very short reply. 0.26. What is the difference between the Rent(as % of GDP) of OECD members in 2010 and the Rent(as % of GDP) of Mauritania in 2012?
Provide a succinct answer. -38.14. What is the difference between the Rent(as % of GDP) in OECD members in 2010 and the Rent(as % of GDP) in Montenegro in 2012?
Your response must be concise. 0.36. What is the difference between the Rent(as % of GDP) in Mauritania in 2010 and the Rent(as % of GDP) in Montenegro in 2012?
Offer a terse response. 43.72. What is the difference between the Rent(as % of GDP) in Central Europe in 2011 and the Rent(as % of GDP) in OECD members in 2012?
Your response must be concise. -0.08. What is the difference between the Rent(as % of GDP) of Central Europe in 2011 and the Rent(as % of GDP) of Mauritania in 2012?
Make the answer very short. -38.2. What is the difference between the Rent(as % of GDP) in Central Europe in 2011 and the Rent(as % of GDP) in Montenegro in 2012?
Provide a short and direct response. 0.31. What is the difference between the Rent(as % of GDP) in OECD members in 2011 and the Rent(as % of GDP) in Mauritania in 2012?
Offer a very short reply. -38.06. What is the difference between the Rent(as % of GDP) in OECD members in 2011 and the Rent(as % of GDP) in Montenegro in 2012?
Your answer should be compact. 0.44. What is the difference between the Rent(as % of GDP) in Mauritania in 2011 and the Rent(as % of GDP) in Montenegro in 2012?
Give a very brief answer. 42.6. What is the average Rent(as % of GDP) in Central Europe per year?
Provide a short and direct response. 0.27. What is the average Rent(as % of GDP) of OECD members per year?
Provide a succinct answer. 0.31. What is the average Rent(as % of GDP) of Mauritania per year?
Provide a short and direct response. 34.96. What is the average Rent(as % of GDP) in Montenegro per year?
Your answer should be very brief. 0.13. In the year 2005, what is the difference between the Rent(as % of GDP) in Central Europe and Rent(as % of GDP) in OECD members?
Provide a succinct answer. 0.04. In the year 2005, what is the difference between the Rent(as % of GDP) in Central Europe and Rent(as % of GDP) in Mauritania?
Offer a terse response. -23.68. In the year 2005, what is the difference between the Rent(as % of GDP) in Central Europe and Rent(as % of GDP) in Montenegro?
Keep it short and to the point. -0.13. In the year 2005, what is the difference between the Rent(as % of GDP) in OECD members and Rent(as % of GDP) in Mauritania?
Give a very brief answer. -23.72. In the year 2005, what is the difference between the Rent(as % of GDP) in OECD members and Rent(as % of GDP) in Montenegro?
Offer a very short reply. -0.17. In the year 2005, what is the difference between the Rent(as % of GDP) of Mauritania and Rent(as % of GDP) of Montenegro?
Make the answer very short. 23.55. In the year 2006, what is the difference between the Rent(as % of GDP) of Central Europe and Rent(as % of GDP) of OECD members?
Give a very brief answer. 0.13. In the year 2006, what is the difference between the Rent(as % of GDP) in Central Europe and Rent(as % of GDP) in Mauritania?
Offer a terse response. -18.36. In the year 2006, what is the difference between the Rent(as % of GDP) in Central Europe and Rent(as % of GDP) in Montenegro?
Your response must be concise. 0.06. In the year 2006, what is the difference between the Rent(as % of GDP) in OECD members and Rent(as % of GDP) in Mauritania?
Your answer should be very brief. -18.49. In the year 2006, what is the difference between the Rent(as % of GDP) in OECD members and Rent(as % of GDP) in Montenegro?
Offer a very short reply. -0.07. In the year 2006, what is the difference between the Rent(as % of GDP) in Mauritania and Rent(as % of GDP) in Montenegro?
Keep it short and to the point. 18.42. In the year 2007, what is the difference between the Rent(as % of GDP) in Central Europe and Rent(as % of GDP) in OECD members?
Your answer should be very brief. -0.02. In the year 2007, what is the difference between the Rent(as % of GDP) in Central Europe and Rent(as % of GDP) in Mauritania?
Your response must be concise. -42.12. In the year 2007, what is the difference between the Rent(as % of GDP) of Central Europe and Rent(as % of GDP) of Montenegro?
Provide a short and direct response. 0.03. In the year 2007, what is the difference between the Rent(as % of GDP) in OECD members and Rent(as % of GDP) in Mauritania?
Your answer should be very brief. -42.1. In the year 2007, what is the difference between the Rent(as % of GDP) in OECD members and Rent(as % of GDP) in Montenegro?
Your answer should be compact. 0.05. In the year 2007, what is the difference between the Rent(as % of GDP) in Mauritania and Rent(as % of GDP) in Montenegro?
Ensure brevity in your answer.  42.15. In the year 2008, what is the difference between the Rent(as % of GDP) in Central Europe and Rent(as % of GDP) in OECD members?
Ensure brevity in your answer.  -0.12. In the year 2008, what is the difference between the Rent(as % of GDP) in Central Europe and Rent(as % of GDP) in Mauritania?
Give a very brief answer. -44.43. In the year 2008, what is the difference between the Rent(as % of GDP) in Central Europe and Rent(as % of GDP) in Montenegro?
Keep it short and to the point. 0.08. In the year 2008, what is the difference between the Rent(as % of GDP) in OECD members and Rent(as % of GDP) in Mauritania?
Provide a short and direct response. -44.31. In the year 2008, what is the difference between the Rent(as % of GDP) in OECD members and Rent(as % of GDP) in Montenegro?
Ensure brevity in your answer.  0.21. In the year 2008, what is the difference between the Rent(as % of GDP) of Mauritania and Rent(as % of GDP) of Montenegro?
Give a very brief answer. 44.52. In the year 2009, what is the difference between the Rent(as % of GDP) in Central Europe and Rent(as % of GDP) in OECD members?
Your answer should be very brief. -0.04. In the year 2009, what is the difference between the Rent(as % of GDP) of Central Europe and Rent(as % of GDP) of Mauritania?
Make the answer very short. -24.97. In the year 2009, what is the difference between the Rent(as % of GDP) of Central Europe and Rent(as % of GDP) of Montenegro?
Provide a succinct answer. 0.16. In the year 2009, what is the difference between the Rent(as % of GDP) of OECD members and Rent(as % of GDP) of Mauritania?
Your answer should be very brief. -24.93. In the year 2009, what is the difference between the Rent(as % of GDP) in OECD members and Rent(as % of GDP) in Montenegro?
Keep it short and to the point. 0.2. In the year 2009, what is the difference between the Rent(as % of GDP) of Mauritania and Rent(as % of GDP) of Montenegro?
Your answer should be compact. 25.13. In the year 2010, what is the difference between the Rent(as % of GDP) in Central Europe and Rent(as % of GDP) in OECD members?
Your answer should be compact. -0.1. In the year 2010, what is the difference between the Rent(as % of GDP) of Central Europe and Rent(as % of GDP) of Mauritania?
Make the answer very short. -43.46. In the year 2010, what is the difference between the Rent(as % of GDP) of Central Europe and Rent(as % of GDP) of Montenegro?
Your answer should be compact. 0.26. In the year 2010, what is the difference between the Rent(as % of GDP) of OECD members and Rent(as % of GDP) of Mauritania?
Provide a succinct answer. -43.35. In the year 2010, what is the difference between the Rent(as % of GDP) in OECD members and Rent(as % of GDP) in Montenegro?
Your response must be concise. 0.36. In the year 2010, what is the difference between the Rent(as % of GDP) in Mauritania and Rent(as % of GDP) in Montenegro?
Provide a short and direct response. 43.72. In the year 2011, what is the difference between the Rent(as % of GDP) of Central Europe and Rent(as % of GDP) of OECD members?
Provide a short and direct response. -0.13. In the year 2011, what is the difference between the Rent(as % of GDP) of Central Europe and Rent(as % of GDP) of Mauritania?
Your answer should be very brief. -42.29. In the year 2011, what is the difference between the Rent(as % of GDP) in Central Europe and Rent(as % of GDP) in Montenegro?
Keep it short and to the point. 0.31. In the year 2011, what is the difference between the Rent(as % of GDP) in OECD members and Rent(as % of GDP) in Mauritania?
Make the answer very short. -42.16. In the year 2011, what is the difference between the Rent(as % of GDP) in OECD members and Rent(as % of GDP) in Montenegro?
Offer a very short reply. 0.44. In the year 2011, what is the difference between the Rent(as % of GDP) in Mauritania and Rent(as % of GDP) in Montenegro?
Provide a short and direct response. 42.6. In the year 2012, what is the difference between the Rent(as % of GDP) in Central Europe and Rent(as % of GDP) in OECD members?
Your answer should be compact. -0.1. In the year 2012, what is the difference between the Rent(as % of GDP) in Central Europe and Rent(as % of GDP) in Mauritania?
Your answer should be very brief. -38.22. In the year 2012, what is the difference between the Rent(as % of GDP) in Central Europe and Rent(as % of GDP) in Montenegro?
Your answer should be very brief. 0.28. In the year 2012, what is the difference between the Rent(as % of GDP) of OECD members and Rent(as % of GDP) of Mauritania?
Your answer should be very brief. -38.12. In the year 2012, what is the difference between the Rent(as % of GDP) of OECD members and Rent(as % of GDP) of Montenegro?
Your response must be concise. 0.38. In the year 2012, what is the difference between the Rent(as % of GDP) in Mauritania and Rent(as % of GDP) in Montenegro?
Provide a succinct answer. 38.51. What is the ratio of the Rent(as % of GDP) in Central Europe in 2005 to that in 2006?
Give a very brief answer. 0.47. What is the ratio of the Rent(as % of GDP) of OECD members in 2005 to that in 2006?
Your response must be concise. 0.55. What is the ratio of the Rent(as % of GDP) of Mauritania in 2005 to that in 2006?
Offer a terse response. 1.27. What is the ratio of the Rent(as % of GDP) of Montenegro in 2005 to that in 2006?
Provide a succinct answer. 0.97. What is the ratio of the Rent(as % of GDP) of Central Europe in 2005 to that in 2007?
Make the answer very short. 0.59. What is the ratio of the Rent(as % of GDP) in OECD members in 2005 to that in 2007?
Ensure brevity in your answer.  0.43. What is the ratio of the Rent(as % of GDP) of Mauritania in 2005 to that in 2007?
Offer a very short reply. 0.56. What is the ratio of the Rent(as % of GDP) of Montenegro in 2005 to that in 2007?
Make the answer very short. 1.12. What is the ratio of the Rent(as % of GDP) in Central Europe in 2005 to that in 2008?
Your response must be concise. 0.83. What is the ratio of the Rent(as % of GDP) in OECD members in 2005 to that in 2008?
Give a very brief answer. 0.41. What is the ratio of the Rent(as % of GDP) of Mauritania in 2005 to that in 2008?
Your response must be concise. 0.53. What is the ratio of the Rent(as % of GDP) in Montenegro in 2005 to that in 2008?
Offer a very short reply. 2.36. What is the ratio of the Rent(as % of GDP) of Central Europe in 2005 to that in 2009?
Your answer should be very brief. 0.99. What is the ratio of the Rent(as % of GDP) of OECD members in 2005 to that in 2009?
Provide a succinct answer. 0.64. What is the ratio of the Rent(as % of GDP) in Mauritania in 2005 to that in 2009?
Make the answer very short. 0.95. What is the ratio of the Rent(as % of GDP) of Montenegro in 2005 to that in 2009?
Ensure brevity in your answer.  23.45. What is the ratio of the Rent(as % of GDP) in Central Europe in 2005 to that in 2010?
Give a very brief answer. 0.64. What is the ratio of the Rent(as % of GDP) of OECD members in 2005 to that in 2010?
Offer a terse response. 0.36. What is the ratio of the Rent(as % of GDP) in Mauritania in 2005 to that in 2010?
Offer a terse response. 0.55. What is the ratio of the Rent(as % of GDP) in Montenegro in 2005 to that in 2010?
Ensure brevity in your answer.  20.15. What is the ratio of the Rent(as % of GDP) in Central Europe in 2005 to that in 2011?
Offer a very short reply. 0.54. What is the ratio of the Rent(as % of GDP) of OECD members in 2005 to that in 2011?
Your response must be concise. 0.3. What is the ratio of the Rent(as % of GDP) of Mauritania in 2005 to that in 2011?
Offer a terse response. 0.56. What is the ratio of the Rent(as % of GDP) in Montenegro in 2005 to that in 2011?
Offer a very short reply. 19.59. What is the ratio of the Rent(as % of GDP) of Central Europe in 2005 to that in 2012?
Offer a terse response. 0.59. What is the ratio of the Rent(as % of GDP) in OECD members in 2005 to that in 2012?
Your answer should be compact. 0.34. What is the ratio of the Rent(as % of GDP) of Mauritania in 2005 to that in 2012?
Provide a short and direct response. 0.62. What is the ratio of the Rent(as % of GDP) in Montenegro in 2005 to that in 2012?
Give a very brief answer. 20.8. What is the ratio of the Rent(as % of GDP) in Central Europe in 2006 to that in 2007?
Your response must be concise. 1.25. What is the ratio of the Rent(as % of GDP) of Mauritania in 2006 to that in 2007?
Give a very brief answer. 0.44. What is the ratio of the Rent(as % of GDP) in Montenegro in 2006 to that in 2007?
Provide a succinct answer. 1.16. What is the ratio of the Rent(as % of GDP) of Central Europe in 2006 to that in 2008?
Offer a very short reply. 1.77. What is the ratio of the Rent(as % of GDP) of OECD members in 2006 to that in 2008?
Provide a succinct answer. 0.74. What is the ratio of the Rent(as % of GDP) in Mauritania in 2006 to that in 2008?
Your answer should be very brief. 0.42. What is the ratio of the Rent(as % of GDP) of Montenegro in 2006 to that in 2008?
Your answer should be very brief. 2.44. What is the ratio of the Rent(as % of GDP) in Central Europe in 2006 to that in 2009?
Offer a terse response. 2.11. What is the ratio of the Rent(as % of GDP) in OECD members in 2006 to that in 2009?
Offer a very short reply. 1.16. What is the ratio of the Rent(as % of GDP) in Mauritania in 2006 to that in 2009?
Your answer should be compact. 0.74. What is the ratio of the Rent(as % of GDP) of Montenegro in 2006 to that in 2009?
Offer a very short reply. 24.2. What is the ratio of the Rent(as % of GDP) of Central Europe in 2006 to that in 2010?
Make the answer very short. 1.38. What is the ratio of the Rent(as % of GDP) in OECD members in 2006 to that in 2010?
Provide a succinct answer. 0.66. What is the ratio of the Rent(as % of GDP) in Mauritania in 2006 to that in 2010?
Give a very brief answer. 0.43. What is the ratio of the Rent(as % of GDP) in Montenegro in 2006 to that in 2010?
Give a very brief answer. 20.79. What is the ratio of the Rent(as % of GDP) of Central Europe in 2006 to that in 2011?
Offer a very short reply. 1.16. What is the ratio of the Rent(as % of GDP) in OECD members in 2006 to that in 2011?
Keep it short and to the point. 0.54. What is the ratio of the Rent(as % of GDP) of Mauritania in 2006 to that in 2011?
Keep it short and to the point. 0.44. What is the ratio of the Rent(as % of GDP) in Montenegro in 2006 to that in 2011?
Offer a very short reply. 20.21. What is the ratio of the Rent(as % of GDP) of Central Europe in 2006 to that in 2012?
Give a very brief answer. 1.26. What is the ratio of the Rent(as % of GDP) of OECD members in 2006 to that in 2012?
Your answer should be compact. 0.62. What is the ratio of the Rent(as % of GDP) in Mauritania in 2006 to that in 2012?
Your answer should be very brief. 0.49. What is the ratio of the Rent(as % of GDP) in Montenegro in 2006 to that in 2012?
Provide a short and direct response. 21.46. What is the ratio of the Rent(as % of GDP) of Central Europe in 2007 to that in 2008?
Ensure brevity in your answer.  1.41. What is the ratio of the Rent(as % of GDP) of OECD members in 2007 to that in 2008?
Offer a terse response. 0.95. What is the ratio of the Rent(as % of GDP) in Mauritania in 2007 to that in 2008?
Make the answer very short. 0.95. What is the ratio of the Rent(as % of GDP) in Montenegro in 2007 to that in 2008?
Provide a short and direct response. 2.1. What is the ratio of the Rent(as % of GDP) in Central Europe in 2007 to that in 2009?
Offer a terse response. 1.68. What is the ratio of the Rent(as % of GDP) of OECD members in 2007 to that in 2009?
Offer a terse response. 1.49. What is the ratio of the Rent(as % of GDP) in Mauritania in 2007 to that in 2009?
Offer a terse response. 1.69. What is the ratio of the Rent(as % of GDP) of Montenegro in 2007 to that in 2009?
Your answer should be very brief. 20.89. What is the ratio of the Rent(as % of GDP) of Central Europe in 2007 to that in 2010?
Make the answer very short. 1.1. What is the ratio of the Rent(as % of GDP) of OECD members in 2007 to that in 2010?
Your answer should be compact. 0.84. What is the ratio of the Rent(as % of GDP) in Mauritania in 2007 to that in 2010?
Offer a terse response. 0.97. What is the ratio of the Rent(as % of GDP) in Montenegro in 2007 to that in 2010?
Give a very brief answer. 17.95. What is the ratio of the Rent(as % of GDP) of Central Europe in 2007 to that in 2011?
Provide a short and direct response. 0.93. What is the ratio of the Rent(as % of GDP) of OECD members in 2007 to that in 2011?
Your answer should be very brief. 0.7. What is the ratio of the Rent(as % of GDP) in Montenegro in 2007 to that in 2011?
Provide a succinct answer. 17.45. What is the ratio of the Rent(as % of GDP) in OECD members in 2007 to that in 2012?
Give a very brief answer. 0.8. What is the ratio of the Rent(as % of GDP) of Mauritania in 2007 to that in 2012?
Offer a very short reply. 1.1. What is the ratio of the Rent(as % of GDP) of Montenegro in 2007 to that in 2012?
Offer a very short reply. 18.52. What is the ratio of the Rent(as % of GDP) in Central Europe in 2008 to that in 2009?
Your response must be concise. 1.2. What is the ratio of the Rent(as % of GDP) of OECD members in 2008 to that in 2009?
Your answer should be compact. 1.57. What is the ratio of the Rent(as % of GDP) in Mauritania in 2008 to that in 2009?
Ensure brevity in your answer.  1.78. What is the ratio of the Rent(as % of GDP) of Montenegro in 2008 to that in 2009?
Your response must be concise. 9.93. What is the ratio of the Rent(as % of GDP) of Central Europe in 2008 to that in 2010?
Offer a very short reply. 0.78. What is the ratio of the Rent(as % of GDP) of OECD members in 2008 to that in 2010?
Ensure brevity in your answer.  0.89. What is the ratio of the Rent(as % of GDP) of Mauritania in 2008 to that in 2010?
Provide a short and direct response. 1.02. What is the ratio of the Rent(as % of GDP) in Montenegro in 2008 to that in 2010?
Offer a terse response. 8.53. What is the ratio of the Rent(as % of GDP) in Central Europe in 2008 to that in 2011?
Provide a succinct answer. 0.66. What is the ratio of the Rent(as % of GDP) of OECD members in 2008 to that in 2011?
Your answer should be very brief. 0.74. What is the ratio of the Rent(as % of GDP) in Mauritania in 2008 to that in 2011?
Your answer should be very brief. 1.05. What is the ratio of the Rent(as % of GDP) in Montenegro in 2008 to that in 2011?
Offer a terse response. 8.3. What is the ratio of the Rent(as % of GDP) of Central Europe in 2008 to that in 2012?
Offer a very short reply. 0.71. What is the ratio of the Rent(as % of GDP) in OECD members in 2008 to that in 2012?
Keep it short and to the point. 0.84. What is the ratio of the Rent(as % of GDP) in Mauritania in 2008 to that in 2012?
Offer a very short reply. 1.16. What is the ratio of the Rent(as % of GDP) in Montenegro in 2008 to that in 2012?
Your answer should be very brief. 8.81. What is the ratio of the Rent(as % of GDP) in Central Europe in 2009 to that in 2010?
Ensure brevity in your answer.  0.65. What is the ratio of the Rent(as % of GDP) in OECD members in 2009 to that in 2010?
Ensure brevity in your answer.  0.57. What is the ratio of the Rent(as % of GDP) of Mauritania in 2009 to that in 2010?
Your answer should be compact. 0.57. What is the ratio of the Rent(as % of GDP) in Montenegro in 2009 to that in 2010?
Offer a very short reply. 0.86. What is the ratio of the Rent(as % of GDP) of Central Europe in 2009 to that in 2011?
Keep it short and to the point. 0.55. What is the ratio of the Rent(as % of GDP) in OECD members in 2009 to that in 2011?
Your answer should be very brief. 0.47. What is the ratio of the Rent(as % of GDP) of Mauritania in 2009 to that in 2011?
Make the answer very short. 0.59. What is the ratio of the Rent(as % of GDP) of Montenegro in 2009 to that in 2011?
Provide a succinct answer. 0.84. What is the ratio of the Rent(as % of GDP) in Central Europe in 2009 to that in 2012?
Your answer should be compact. 0.59. What is the ratio of the Rent(as % of GDP) in OECD members in 2009 to that in 2012?
Keep it short and to the point. 0.53. What is the ratio of the Rent(as % of GDP) in Mauritania in 2009 to that in 2012?
Your answer should be compact. 0.65. What is the ratio of the Rent(as % of GDP) in Montenegro in 2009 to that in 2012?
Offer a terse response. 0.89. What is the ratio of the Rent(as % of GDP) in Central Europe in 2010 to that in 2011?
Give a very brief answer. 0.84. What is the ratio of the Rent(as % of GDP) in OECD members in 2010 to that in 2011?
Make the answer very short. 0.83. What is the ratio of the Rent(as % of GDP) of Mauritania in 2010 to that in 2011?
Offer a terse response. 1.03. What is the ratio of the Rent(as % of GDP) in Montenegro in 2010 to that in 2011?
Provide a short and direct response. 0.97. What is the ratio of the Rent(as % of GDP) of Central Europe in 2010 to that in 2012?
Offer a very short reply. 0.91. What is the ratio of the Rent(as % of GDP) in OECD members in 2010 to that in 2012?
Offer a terse response. 0.94. What is the ratio of the Rent(as % of GDP) of Mauritania in 2010 to that in 2012?
Provide a succinct answer. 1.14. What is the ratio of the Rent(as % of GDP) in Montenegro in 2010 to that in 2012?
Provide a short and direct response. 1.03. What is the ratio of the Rent(as % of GDP) of Central Europe in 2011 to that in 2012?
Your answer should be compact. 1.08. What is the ratio of the Rent(as % of GDP) of OECD members in 2011 to that in 2012?
Your response must be concise. 1.14. What is the ratio of the Rent(as % of GDP) in Mauritania in 2011 to that in 2012?
Give a very brief answer. 1.11. What is the ratio of the Rent(as % of GDP) of Montenegro in 2011 to that in 2012?
Your answer should be compact. 1.06. What is the difference between the highest and the second highest Rent(as % of GDP) in Central Europe?
Keep it short and to the point. 0.05. What is the difference between the highest and the second highest Rent(as % of GDP) in OECD members?
Your answer should be very brief. 0.06. What is the difference between the highest and the second highest Rent(as % of GDP) of Mauritania?
Offer a very short reply. 0.91. What is the difference between the highest and the second highest Rent(as % of GDP) of Montenegro?
Your response must be concise. 0.01. What is the difference between the highest and the lowest Rent(as % of GDP) of Central Europe?
Your answer should be very brief. 0.2. What is the difference between the highest and the lowest Rent(as % of GDP) in OECD members?
Provide a short and direct response. 0.32. What is the difference between the highest and the lowest Rent(as % of GDP) of Mauritania?
Your answer should be very brief. 25.91. What is the difference between the highest and the lowest Rent(as % of GDP) in Montenegro?
Your response must be concise. 0.3. 